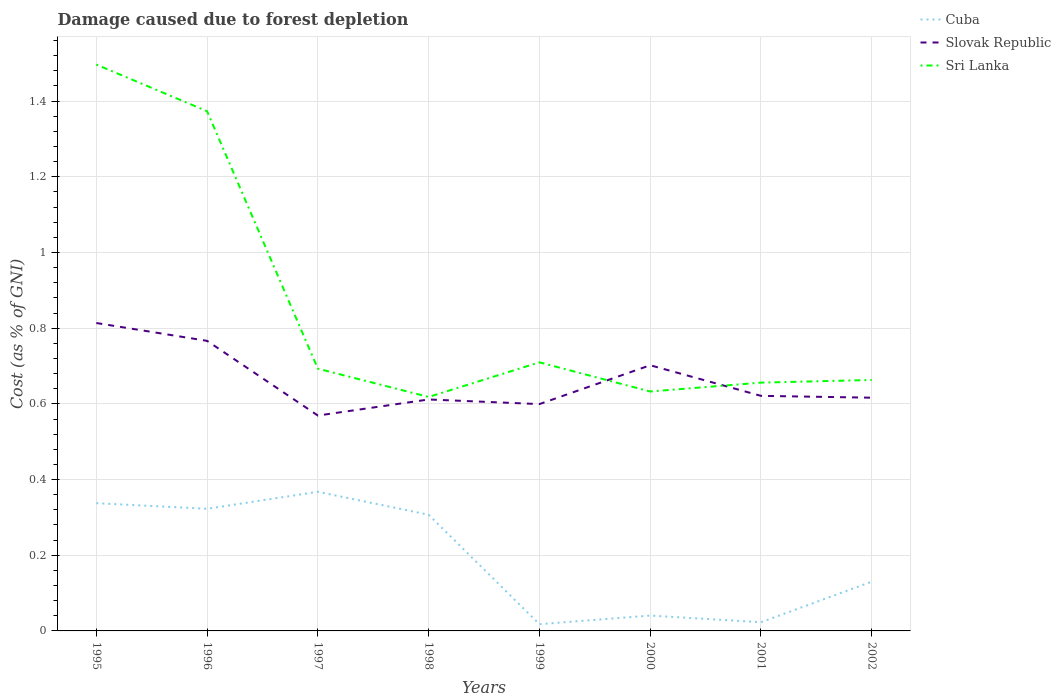How many different coloured lines are there?
Offer a very short reply. 3. Is the number of lines equal to the number of legend labels?
Keep it short and to the point. Yes. Across all years, what is the maximum cost of damage caused due to forest depletion in Sri Lanka?
Your response must be concise. 0.62. In which year was the cost of damage caused due to forest depletion in Cuba maximum?
Make the answer very short. 1999. What is the total cost of damage caused due to forest depletion in Cuba in the graph?
Offer a very short reply. 0.35. What is the difference between the highest and the second highest cost of damage caused due to forest depletion in Slovak Republic?
Offer a terse response. 0.24. What is the difference between the highest and the lowest cost of damage caused due to forest depletion in Slovak Republic?
Your answer should be compact. 3. How many lines are there?
Your answer should be very brief. 3. How many years are there in the graph?
Offer a very short reply. 8. What is the difference between two consecutive major ticks on the Y-axis?
Your response must be concise. 0.2. Does the graph contain grids?
Your answer should be very brief. Yes. How many legend labels are there?
Your answer should be very brief. 3. What is the title of the graph?
Ensure brevity in your answer.  Damage caused due to forest depletion. Does "Bulgaria" appear as one of the legend labels in the graph?
Your response must be concise. No. What is the label or title of the X-axis?
Keep it short and to the point. Years. What is the label or title of the Y-axis?
Your response must be concise. Cost (as % of GNI). What is the Cost (as % of GNI) of Cuba in 1995?
Provide a short and direct response. 0.34. What is the Cost (as % of GNI) of Slovak Republic in 1995?
Your answer should be compact. 0.81. What is the Cost (as % of GNI) in Sri Lanka in 1995?
Ensure brevity in your answer.  1.5. What is the Cost (as % of GNI) in Cuba in 1996?
Your response must be concise. 0.32. What is the Cost (as % of GNI) in Slovak Republic in 1996?
Make the answer very short. 0.77. What is the Cost (as % of GNI) in Sri Lanka in 1996?
Your response must be concise. 1.37. What is the Cost (as % of GNI) in Cuba in 1997?
Ensure brevity in your answer.  0.37. What is the Cost (as % of GNI) in Slovak Republic in 1997?
Your answer should be very brief. 0.57. What is the Cost (as % of GNI) of Sri Lanka in 1997?
Offer a terse response. 0.69. What is the Cost (as % of GNI) of Cuba in 1998?
Offer a terse response. 0.31. What is the Cost (as % of GNI) in Slovak Republic in 1998?
Your answer should be compact. 0.61. What is the Cost (as % of GNI) in Sri Lanka in 1998?
Provide a short and direct response. 0.62. What is the Cost (as % of GNI) of Cuba in 1999?
Offer a very short reply. 0.02. What is the Cost (as % of GNI) of Slovak Republic in 1999?
Your answer should be very brief. 0.6. What is the Cost (as % of GNI) of Sri Lanka in 1999?
Provide a short and direct response. 0.71. What is the Cost (as % of GNI) of Cuba in 2000?
Give a very brief answer. 0.04. What is the Cost (as % of GNI) in Slovak Republic in 2000?
Your answer should be very brief. 0.7. What is the Cost (as % of GNI) of Sri Lanka in 2000?
Offer a terse response. 0.63. What is the Cost (as % of GNI) of Cuba in 2001?
Keep it short and to the point. 0.02. What is the Cost (as % of GNI) in Slovak Republic in 2001?
Provide a short and direct response. 0.62. What is the Cost (as % of GNI) of Sri Lanka in 2001?
Your answer should be compact. 0.66. What is the Cost (as % of GNI) in Cuba in 2002?
Give a very brief answer. 0.13. What is the Cost (as % of GNI) of Slovak Republic in 2002?
Your response must be concise. 0.62. What is the Cost (as % of GNI) of Sri Lanka in 2002?
Offer a very short reply. 0.66. Across all years, what is the maximum Cost (as % of GNI) of Cuba?
Your response must be concise. 0.37. Across all years, what is the maximum Cost (as % of GNI) of Slovak Republic?
Keep it short and to the point. 0.81. Across all years, what is the maximum Cost (as % of GNI) in Sri Lanka?
Your answer should be compact. 1.5. Across all years, what is the minimum Cost (as % of GNI) of Cuba?
Give a very brief answer. 0.02. Across all years, what is the minimum Cost (as % of GNI) in Slovak Republic?
Your answer should be compact. 0.57. Across all years, what is the minimum Cost (as % of GNI) in Sri Lanka?
Provide a short and direct response. 0.62. What is the total Cost (as % of GNI) in Cuba in the graph?
Offer a terse response. 1.55. What is the total Cost (as % of GNI) of Slovak Republic in the graph?
Give a very brief answer. 5.3. What is the total Cost (as % of GNI) of Sri Lanka in the graph?
Your response must be concise. 6.84. What is the difference between the Cost (as % of GNI) in Cuba in 1995 and that in 1996?
Your answer should be very brief. 0.01. What is the difference between the Cost (as % of GNI) in Slovak Republic in 1995 and that in 1996?
Your answer should be very brief. 0.05. What is the difference between the Cost (as % of GNI) of Sri Lanka in 1995 and that in 1996?
Provide a short and direct response. 0.12. What is the difference between the Cost (as % of GNI) of Cuba in 1995 and that in 1997?
Ensure brevity in your answer.  -0.03. What is the difference between the Cost (as % of GNI) in Slovak Republic in 1995 and that in 1997?
Offer a very short reply. 0.24. What is the difference between the Cost (as % of GNI) of Sri Lanka in 1995 and that in 1997?
Keep it short and to the point. 0.8. What is the difference between the Cost (as % of GNI) of Cuba in 1995 and that in 1998?
Keep it short and to the point. 0.03. What is the difference between the Cost (as % of GNI) in Slovak Republic in 1995 and that in 1998?
Your answer should be compact. 0.2. What is the difference between the Cost (as % of GNI) of Sri Lanka in 1995 and that in 1998?
Offer a very short reply. 0.88. What is the difference between the Cost (as % of GNI) in Cuba in 1995 and that in 1999?
Ensure brevity in your answer.  0.32. What is the difference between the Cost (as % of GNI) of Slovak Republic in 1995 and that in 1999?
Provide a short and direct response. 0.21. What is the difference between the Cost (as % of GNI) of Sri Lanka in 1995 and that in 1999?
Your response must be concise. 0.79. What is the difference between the Cost (as % of GNI) of Cuba in 1995 and that in 2000?
Offer a terse response. 0.3. What is the difference between the Cost (as % of GNI) of Slovak Republic in 1995 and that in 2000?
Your answer should be very brief. 0.11. What is the difference between the Cost (as % of GNI) in Sri Lanka in 1995 and that in 2000?
Provide a succinct answer. 0.86. What is the difference between the Cost (as % of GNI) of Cuba in 1995 and that in 2001?
Your response must be concise. 0.31. What is the difference between the Cost (as % of GNI) in Slovak Republic in 1995 and that in 2001?
Give a very brief answer. 0.19. What is the difference between the Cost (as % of GNI) of Sri Lanka in 1995 and that in 2001?
Offer a very short reply. 0.84. What is the difference between the Cost (as % of GNI) of Cuba in 1995 and that in 2002?
Make the answer very short. 0.21. What is the difference between the Cost (as % of GNI) in Slovak Republic in 1995 and that in 2002?
Provide a short and direct response. 0.2. What is the difference between the Cost (as % of GNI) in Sri Lanka in 1995 and that in 2002?
Make the answer very short. 0.83. What is the difference between the Cost (as % of GNI) in Cuba in 1996 and that in 1997?
Your answer should be very brief. -0.04. What is the difference between the Cost (as % of GNI) of Slovak Republic in 1996 and that in 1997?
Ensure brevity in your answer.  0.2. What is the difference between the Cost (as % of GNI) of Sri Lanka in 1996 and that in 1997?
Your answer should be compact. 0.68. What is the difference between the Cost (as % of GNI) of Cuba in 1996 and that in 1998?
Your response must be concise. 0.02. What is the difference between the Cost (as % of GNI) in Slovak Republic in 1996 and that in 1998?
Give a very brief answer. 0.15. What is the difference between the Cost (as % of GNI) of Sri Lanka in 1996 and that in 1998?
Your answer should be very brief. 0.76. What is the difference between the Cost (as % of GNI) of Cuba in 1996 and that in 1999?
Ensure brevity in your answer.  0.3. What is the difference between the Cost (as % of GNI) in Slovak Republic in 1996 and that in 1999?
Offer a very short reply. 0.17. What is the difference between the Cost (as % of GNI) in Sri Lanka in 1996 and that in 1999?
Your response must be concise. 0.66. What is the difference between the Cost (as % of GNI) of Cuba in 1996 and that in 2000?
Provide a short and direct response. 0.28. What is the difference between the Cost (as % of GNI) in Slovak Republic in 1996 and that in 2000?
Keep it short and to the point. 0.06. What is the difference between the Cost (as % of GNI) of Sri Lanka in 1996 and that in 2000?
Ensure brevity in your answer.  0.74. What is the difference between the Cost (as % of GNI) of Cuba in 1996 and that in 2001?
Provide a short and direct response. 0.3. What is the difference between the Cost (as % of GNI) of Slovak Republic in 1996 and that in 2001?
Provide a succinct answer. 0.15. What is the difference between the Cost (as % of GNI) in Sri Lanka in 1996 and that in 2001?
Your response must be concise. 0.72. What is the difference between the Cost (as % of GNI) of Cuba in 1996 and that in 2002?
Provide a short and direct response. 0.19. What is the difference between the Cost (as % of GNI) of Slovak Republic in 1996 and that in 2002?
Your response must be concise. 0.15. What is the difference between the Cost (as % of GNI) of Sri Lanka in 1996 and that in 2002?
Make the answer very short. 0.71. What is the difference between the Cost (as % of GNI) of Cuba in 1997 and that in 1998?
Offer a terse response. 0.06. What is the difference between the Cost (as % of GNI) in Slovak Republic in 1997 and that in 1998?
Provide a succinct answer. -0.04. What is the difference between the Cost (as % of GNI) in Sri Lanka in 1997 and that in 1998?
Offer a terse response. 0.07. What is the difference between the Cost (as % of GNI) of Cuba in 1997 and that in 1999?
Offer a very short reply. 0.35. What is the difference between the Cost (as % of GNI) in Slovak Republic in 1997 and that in 1999?
Ensure brevity in your answer.  -0.03. What is the difference between the Cost (as % of GNI) of Sri Lanka in 1997 and that in 1999?
Offer a terse response. -0.02. What is the difference between the Cost (as % of GNI) of Cuba in 1997 and that in 2000?
Keep it short and to the point. 0.33. What is the difference between the Cost (as % of GNI) of Slovak Republic in 1997 and that in 2000?
Make the answer very short. -0.13. What is the difference between the Cost (as % of GNI) in Sri Lanka in 1997 and that in 2000?
Ensure brevity in your answer.  0.06. What is the difference between the Cost (as % of GNI) in Cuba in 1997 and that in 2001?
Give a very brief answer. 0.34. What is the difference between the Cost (as % of GNI) of Slovak Republic in 1997 and that in 2001?
Keep it short and to the point. -0.05. What is the difference between the Cost (as % of GNI) in Sri Lanka in 1997 and that in 2001?
Ensure brevity in your answer.  0.04. What is the difference between the Cost (as % of GNI) of Cuba in 1997 and that in 2002?
Provide a short and direct response. 0.24. What is the difference between the Cost (as % of GNI) in Slovak Republic in 1997 and that in 2002?
Your answer should be very brief. -0.05. What is the difference between the Cost (as % of GNI) in Sri Lanka in 1997 and that in 2002?
Provide a short and direct response. 0.03. What is the difference between the Cost (as % of GNI) in Cuba in 1998 and that in 1999?
Provide a succinct answer. 0.29. What is the difference between the Cost (as % of GNI) of Slovak Republic in 1998 and that in 1999?
Provide a short and direct response. 0.01. What is the difference between the Cost (as % of GNI) of Sri Lanka in 1998 and that in 1999?
Your answer should be compact. -0.09. What is the difference between the Cost (as % of GNI) in Cuba in 1998 and that in 2000?
Give a very brief answer. 0.27. What is the difference between the Cost (as % of GNI) in Slovak Republic in 1998 and that in 2000?
Your answer should be compact. -0.09. What is the difference between the Cost (as % of GNI) in Sri Lanka in 1998 and that in 2000?
Make the answer very short. -0.01. What is the difference between the Cost (as % of GNI) in Cuba in 1998 and that in 2001?
Offer a very short reply. 0.28. What is the difference between the Cost (as % of GNI) of Slovak Republic in 1998 and that in 2001?
Ensure brevity in your answer.  -0.01. What is the difference between the Cost (as % of GNI) in Sri Lanka in 1998 and that in 2001?
Offer a very short reply. -0.04. What is the difference between the Cost (as % of GNI) of Cuba in 1998 and that in 2002?
Keep it short and to the point. 0.18. What is the difference between the Cost (as % of GNI) in Slovak Republic in 1998 and that in 2002?
Offer a terse response. -0. What is the difference between the Cost (as % of GNI) in Sri Lanka in 1998 and that in 2002?
Your response must be concise. -0.04. What is the difference between the Cost (as % of GNI) in Cuba in 1999 and that in 2000?
Keep it short and to the point. -0.02. What is the difference between the Cost (as % of GNI) in Slovak Republic in 1999 and that in 2000?
Provide a short and direct response. -0.1. What is the difference between the Cost (as % of GNI) of Sri Lanka in 1999 and that in 2000?
Your answer should be compact. 0.08. What is the difference between the Cost (as % of GNI) in Cuba in 1999 and that in 2001?
Offer a terse response. -0.01. What is the difference between the Cost (as % of GNI) of Slovak Republic in 1999 and that in 2001?
Provide a succinct answer. -0.02. What is the difference between the Cost (as % of GNI) in Sri Lanka in 1999 and that in 2001?
Provide a succinct answer. 0.05. What is the difference between the Cost (as % of GNI) in Cuba in 1999 and that in 2002?
Your answer should be compact. -0.11. What is the difference between the Cost (as % of GNI) in Slovak Republic in 1999 and that in 2002?
Provide a short and direct response. -0.02. What is the difference between the Cost (as % of GNI) in Sri Lanka in 1999 and that in 2002?
Your answer should be compact. 0.05. What is the difference between the Cost (as % of GNI) in Cuba in 2000 and that in 2001?
Your answer should be very brief. 0.02. What is the difference between the Cost (as % of GNI) of Slovak Republic in 2000 and that in 2001?
Your answer should be very brief. 0.08. What is the difference between the Cost (as % of GNI) in Sri Lanka in 2000 and that in 2001?
Offer a very short reply. -0.02. What is the difference between the Cost (as % of GNI) of Cuba in 2000 and that in 2002?
Your answer should be very brief. -0.09. What is the difference between the Cost (as % of GNI) of Slovak Republic in 2000 and that in 2002?
Keep it short and to the point. 0.09. What is the difference between the Cost (as % of GNI) in Sri Lanka in 2000 and that in 2002?
Offer a terse response. -0.03. What is the difference between the Cost (as % of GNI) of Cuba in 2001 and that in 2002?
Your answer should be very brief. -0.11. What is the difference between the Cost (as % of GNI) in Slovak Republic in 2001 and that in 2002?
Give a very brief answer. 0. What is the difference between the Cost (as % of GNI) in Sri Lanka in 2001 and that in 2002?
Provide a succinct answer. -0.01. What is the difference between the Cost (as % of GNI) of Cuba in 1995 and the Cost (as % of GNI) of Slovak Republic in 1996?
Make the answer very short. -0.43. What is the difference between the Cost (as % of GNI) in Cuba in 1995 and the Cost (as % of GNI) in Sri Lanka in 1996?
Offer a terse response. -1.04. What is the difference between the Cost (as % of GNI) of Slovak Republic in 1995 and the Cost (as % of GNI) of Sri Lanka in 1996?
Offer a terse response. -0.56. What is the difference between the Cost (as % of GNI) in Cuba in 1995 and the Cost (as % of GNI) in Slovak Republic in 1997?
Make the answer very short. -0.23. What is the difference between the Cost (as % of GNI) of Cuba in 1995 and the Cost (as % of GNI) of Sri Lanka in 1997?
Keep it short and to the point. -0.36. What is the difference between the Cost (as % of GNI) in Slovak Republic in 1995 and the Cost (as % of GNI) in Sri Lanka in 1997?
Your answer should be compact. 0.12. What is the difference between the Cost (as % of GNI) in Cuba in 1995 and the Cost (as % of GNI) in Slovak Republic in 1998?
Make the answer very short. -0.27. What is the difference between the Cost (as % of GNI) in Cuba in 1995 and the Cost (as % of GNI) in Sri Lanka in 1998?
Offer a terse response. -0.28. What is the difference between the Cost (as % of GNI) of Slovak Republic in 1995 and the Cost (as % of GNI) of Sri Lanka in 1998?
Offer a terse response. 0.2. What is the difference between the Cost (as % of GNI) in Cuba in 1995 and the Cost (as % of GNI) in Slovak Republic in 1999?
Give a very brief answer. -0.26. What is the difference between the Cost (as % of GNI) of Cuba in 1995 and the Cost (as % of GNI) of Sri Lanka in 1999?
Provide a succinct answer. -0.37. What is the difference between the Cost (as % of GNI) in Slovak Republic in 1995 and the Cost (as % of GNI) in Sri Lanka in 1999?
Offer a very short reply. 0.1. What is the difference between the Cost (as % of GNI) of Cuba in 1995 and the Cost (as % of GNI) of Slovak Republic in 2000?
Offer a terse response. -0.36. What is the difference between the Cost (as % of GNI) of Cuba in 1995 and the Cost (as % of GNI) of Sri Lanka in 2000?
Give a very brief answer. -0.3. What is the difference between the Cost (as % of GNI) in Slovak Republic in 1995 and the Cost (as % of GNI) in Sri Lanka in 2000?
Your answer should be compact. 0.18. What is the difference between the Cost (as % of GNI) in Cuba in 1995 and the Cost (as % of GNI) in Slovak Republic in 2001?
Provide a succinct answer. -0.28. What is the difference between the Cost (as % of GNI) in Cuba in 1995 and the Cost (as % of GNI) in Sri Lanka in 2001?
Offer a terse response. -0.32. What is the difference between the Cost (as % of GNI) of Slovak Republic in 1995 and the Cost (as % of GNI) of Sri Lanka in 2001?
Give a very brief answer. 0.16. What is the difference between the Cost (as % of GNI) of Cuba in 1995 and the Cost (as % of GNI) of Slovak Republic in 2002?
Keep it short and to the point. -0.28. What is the difference between the Cost (as % of GNI) in Cuba in 1995 and the Cost (as % of GNI) in Sri Lanka in 2002?
Make the answer very short. -0.33. What is the difference between the Cost (as % of GNI) in Slovak Republic in 1995 and the Cost (as % of GNI) in Sri Lanka in 2002?
Your response must be concise. 0.15. What is the difference between the Cost (as % of GNI) in Cuba in 1996 and the Cost (as % of GNI) in Slovak Republic in 1997?
Give a very brief answer. -0.25. What is the difference between the Cost (as % of GNI) of Cuba in 1996 and the Cost (as % of GNI) of Sri Lanka in 1997?
Your response must be concise. -0.37. What is the difference between the Cost (as % of GNI) of Slovak Republic in 1996 and the Cost (as % of GNI) of Sri Lanka in 1997?
Your answer should be very brief. 0.07. What is the difference between the Cost (as % of GNI) of Cuba in 1996 and the Cost (as % of GNI) of Slovak Republic in 1998?
Your response must be concise. -0.29. What is the difference between the Cost (as % of GNI) of Cuba in 1996 and the Cost (as % of GNI) of Sri Lanka in 1998?
Provide a succinct answer. -0.3. What is the difference between the Cost (as % of GNI) in Slovak Republic in 1996 and the Cost (as % of GNI) in Sri Lanka in 1998?
Your answer should be very brief. 0.15. What is the difference between the Cost (as % of GNI) of Cuba in 1996 and the Cost (as % of GNI) of Slovak Republic in 1999?
Make the answer very short. -0.28. What is the difference between the Cost (as % of GNI) of Cuba in 1996 and the Cost (as % of GNI) of Sri Lanka in 1999?
Provide a short and direct response. -0.39. What is the difference between the Cost (as % of GNI) in Slovak Republic in 1996 and the Cost (as % of GNI) in Sri Lanka in 1999?
Your response must be concise. 0.06. What is the difference between the Cost (as % of GNI) in Cuba in 1996 and the Cost (as % of GNI) in Slovak Republic in 2000?
Your answer should be compact. -0.38. What is the difference between the Cost (as % of GNI) in Cuba in 1996 and the Cost (as % of GNI) in Sri Lanka in 2000?
Provide a short and direct response. -0.31. What is the difference between the Cost (as % of GNI) of Slovak Republic in 1996 and the Cost (as % of GNI) of Sri Lanka in 2000?
Make the answer very short. 0.13. What is the difference between the Cost (as % of GNI) of Cuba in 1996 and the Cost (as % of GNI) of Slovak Republic in 2001?
Offer a terse response. -0.3. What is the difference between the Cost (as % of GNI) of Cuba in 1996 and the Cost (as % of GNI) of Sri Lanka in 2001?
Provide a short and direct response. -0.33. What is the difference between the Cost (as % of GNI) in Slovak Republic in 1996 and the Cost (as % of GNI) in Sri Lanka in 2001?
Give a very brief answer. 0.11. What is the difference between the Cost (as % of GNI) in Cuba in 1996 and the Cost (as % of GNI) in Slovak Republic in 2002?
Offer a terse response. -0.29. What is the difference between the Cost (as % of GNI) of Cuba in 1996 and the Cost (as % of GNI) of Sri Lanka in 2002?
Your answer should be compact. -0.34. What is the difference between the Cost (as % of GNI) in Slovak Republic in 1996 and the Cost (as % of GNI) in Sri Lanka in 2002?
Make the answer very short. 0.1. What is the difference between the Cost (as % of GNI) of Cuba in 1997 and the Cost (as % of GNI) of Slovak Republic in 1998?
Your answer should be compact. -0.24. What is the difference between the Cost (as % of GNI) of Cuba in 1997 and the Cost (as % of GNI) of Sri Lanka in 1998?
Give a very brief answer. -0.25. What is the difference between the Cost (as % of GNI) in Slovak Republic in 1997 and the Cost (as % of GNI) in Sri Lanka in 1998?
Provide a succinct answer. -0.05. What is the difference between the Cost (as % of GNI) in Cuba in 1997 and the Cost (as % of GNI) in Slovak Republic in 1999?
Make the answer very short. -0.23. What is the difference between the Cost (as % of GNI) of Cuba in 1997 and the Cost (as % of GNI) of Sri Lanka in 1999?
Provide a short and direct response. -0.34. What is the difference between the Cost (as % of GNI) in Slovak Republic in 1997 and the Cost (as % of GNI) in Sri Lanka in 1999?
Offer a very short reply. -0.14. What is the difference between the Cost (as % of GNI) of Cuba in 1997 and the Cost (as % of GNI) of Slovak Republic in 2000?
Ensure brevity in your answer.  -0.33. What is the difference between the Cost (as % of GNI) in Cuba in 1997 and the Cost (as % of GNI) in Sri Lanka in 2000?
Give a very brief answer. -0.27. What is the difference between the Cost (as % of GNI) of Slovak Republic in 1997 and the Cost (as % of GNI) of Sri Lanka in 2000?
Your response must be concise. -0.06. What is the difference between the Cost (as % of GNI) in Cuba in 1997 and the Cost (as % of GNI) in Slovak Republic in 2001?
Make the answer very short. -0.25. What is the difference between the Cost (as % of GNI) in Cuba in 1997 and the Cost (as % of GNI) in Sri Lanka in 2001?
Offer a terse response. -0.29. What is the difference between the Cost (as % of GNI) in Slovak Republic in 1997 and the Cost (as % of GNI) in Sri Lanka in 2001?
Your response must be concise. -0.09. What is the difference between the Cost (as % of GNI) in Cuba in 1997 and the Cost (as % of GNI) in Slovak Republic in 2002?
Your response must be concise. -0.25. What is the difference between the Cost (as % of GNI) in Cuba in 1997 and the Cost (as % of GNI) in Sri Lanka in 2002?
Your answer should be compact. -0.3. What is the difference between the Cost (as % of GNI) in Slovak Republic in 1997 and the Cost (as % of GNI) in Sri Lanka in 2002?
Give a very brief answer. -0.09. What is the difference between the Cost (as % of GNI) in Cuba in 1998 and the Cost (as % of GNI) in Slovak Republic in 1999?
Give a very brief answer. -0.29. What is the difference between the Cost (as % of GNI) in Cuba in 1998 and the Cost (as % of GNI) in Sri Lanka in 1999?
Give a very brief answer. -0.4. What is the difference between the Cost (as % of GNI) in Slovak Republic in 1998 and the Cost (as % of GNI) in Sri Lanka in 1999?
Give a very brief answer. -0.1. What is the difference between the Cost (as % of GNI) of Cuba in 1998 and the Cost (as % of GNI) of Slovak Republic in 2000?
Give a very brief answer. -0.4. What is the difference between the Cost (as % of GNI) in Cuba in 1998 and the Cost (as % of GNI) in Sri Lanka in 2000?
Offer a terse response. -0.33. What is the difference between the Cost (as % of GNI) of Slovak Republic in 1998 and the Cost (as % of GNI) of Sri Lanka in 2000?
Offer a very short reply. -0.02. What is the difference between the Cost (as % of GNI) in Cuba in 1998 and the Cost (as % of GNI) in Slovak Republic in 2001?
Your response must be concise. -0.31. What is the difference between the Cost (as % of GNI) of Cuba in 1998 and the Cost (as % of GNI) of Sri Lanka in 2001?
Your answer should be very brief. -0.35. What is the difference between the Cost (as % of GNI) of Slovak Republic in 1998 and the Cost (as % of GNI) of Sri Lanka in 2001?
Your answer should be compact. -0.04. What is the difference between the Cost (as % of GNI) in Cuba in 1998 and the Cost (as % of GNI) in Slovak Republic in 2002?
Your answer should be compact. -0.31. What is the difference between the Cost (as % of GNI) in Cuba in 1998 and the Cost (as % of GNI) in Sri Lanka in 2002?
Make the answer very short. -0.36. What is the difference between the Cost (as % of GNI) of Slovak Republic in 1998 and the Cost (as % of GNI) of Sri Lanka in 2002?
Offer a terse response. -0.05. What is the difference between the Cost (as % of GNI) of Cuba in 1999 and the Cost (as % of GNI) of Slovak Republic in 2000?
Make the answer very short. -0.68. What is the difference between the Cost (as % of GNI) of Cuba in 1999 and the Cost (as % of GNI) of Sri Lanka in 2000?
Ensure brevity in your answer.  -0.61. What is the difference between the Cost (as % of GNI) in Slovak Republic in 1999 and the Cost (as % of GNI) in Sri Lanka in 2000?
Your answer should be very brief. -0.03. What is the difference between the Cost (as % of GNI) of Cuba in 1999 and the Cost (as % of GNI) of Slovak Republic in 2001?
Provide a short and direct response. -0.6. What is the difference between the Cost (as % of GNI) in Cuba in 1999 and the Cost (as % of GNI) in Sri Lanka in 2001?
Your answer should be very brief. -0.64. What is the difference between the Cost (as % of GNI) of Slovak Republic in 1999 and the Cost (as % of GNI) of Sri Lanka in 2001?
Provide a succinct answer. -0.06. What is the difference between the Cost (as % of GNI) of Cuba in 1999 and the Cost (as % of GNI) of Slovak Republic in 2002?
Your answer should be very brief. -0.6. What is the difference between the Cost (as % of GNI) of Cuba in 1999 and the Cost (as % of GNI) of Sri Lanka in 2002?
Provide a short and direct response. -0.65. What is the difference between the Cost (as % of GNI) of Slovak Republic in 1999 and the Cost (as % of GNI) of Sri Lanka in 2002?
Ensure brevity in your answer.  -0.06. What is the difference between the Cost (as % of GNI) in Cuba in 2000 and the Cost (as % of GNI) in Slovak Republic in 2001?
Offer a very short reply. -0.58. What is the difference between the Cost (as % of GNI) in Cuba in 2000 and the Cost (as % of GNI) in Sri Lanka in 2001?
Your answer should be compact. -0.62. What is the difference between the Cost (as % of GNI) in Slovak Republic in 2000 and the Cost (as % of GNI) in Sri Lanka in 2001?
Your response must be concise. 0.05. What is the difference between the Cost (as % of GNI) in Cuba in 2000 and the Cost (as % of GNI) in Slovak Republic in 2002?
Keep it short and to the point. -0.58. What is the difference between the Cost (as % of GNI) of Cuba in 2000 and the Cost (as % of GNI) of Sri Lanka in 2002?
Give a very brief answer. -0.62. What is the difference between the Cost (as % of GNI) of Slovak Republic in 2000 and the Cost (as % of GNI) of Sri Lanka in 2002?
Your answer should be very brief. 0.04. What is the difference between the Cost (as % of GNI) of Cuba in 2001 and the Cost (as % of GNI) of Slovak Republic in 2002?
Offer a very short reply. -0.59. What is the difference between the Cost (as % of GNI) in Cuba in 2001 and the Cost (as % of GNI) in Sri Lanka in 2002?
Offer a very short reply. -0.64. What is the difference between the Cost (as % of GNI) in Slovak Republic in 2001 and the Cost (as % of GNI) in Sri Lanka in 2002?
Your answer should be compact. -0.04. What is the average Cost (as % of GNI) of Cuba per year?
Provide a succinct answer. 0.19. What is the average Cost (as % of GNI) in Slovak Republic per year?
Ensure brevity in your answer.  0.66. What is the average Cost (as % of GNI) of Sri Lanka per year?
Make the answer very short. 0.86. In the year 1995, what is the difference between the Cost (as % of GNI) in Cuba and Cost (as % of GNI) in Slovak Republic?
Your response must be concise. -0.48. In the year 1995, what is the difference between the Cost (as % of GNI) in Cuba and Cost (as % of GNI) in Sri Lanka?
Provide a short and direct response. -1.16. In the year 1995, what is the difference between the Cost (as % of GNI) in Slovak Republic and Cost (as % of GNI) in Sri Lanka?
Your answer should be compact. -0.68. In the year 1996, what is the difference between the Cost (as % of GNI) in Cuba and Cost (as % of GNI) in Slovak Republic?
Keep it short and to the point. -0.44. In the year 1996, what is the difference between the Cost (as % of GNI) of Cuba and Cost (as % of GNI) of Sri Lanka?
Your response must be concise. -1.05. In the year 1996, what is the difference between the Cost (as % of GNI) of Slovak Republic and Cost (as % of GNI) of Sri Lanka?
Your answer should be very brief. -0.61. In the year 1997, what is the difference between the Cost (as % of GNI) of Cuba and Cost (as % of GNI) of Slovak Republic?
Your response must be concise. -0.2. In the year 1997, what is the difference between the Cost (as % of GNI) in Cuba and Cost (as % of GNI) in Sri Lanka?
Your answer should be compact. -0.33. In the year 1997, what is the difference between the Cost (as % of GNI) in Slovak Republic and Cost (as % of GNI) in Sri Lanka?
Give a very brief answer. -0.12. In the year 1998, what is the difference between the Cost (as % of GNI) in Cuba and Cost (as % of GNI) in Slovak Republic?
Give a very brief answer. -0.3. In the year 1998, what is the difference between the Cost (as % of GNI) in Cuba and Cost (as % of GNI) in Sri Lanka?
Your answer should be very brief. -0.31. In the year 1998, what is the difference between the Cost (as % of GNI) of Slovak Republic and Cost (as % of GNI) of Sri Lanka?
Offer a very short reply. -0.01. In the year 1999, what is the difference between the Cost (as % of GNI) in Cuba and Cost (as % of GNI) in Slovak Republic?
Offer a very short reply. -0.58. In the year 1999, what is the difference between the Cost (as % of GNI) in Cuba and Cost (as % of GNI) in Sri Lanka?
Keep it short and to the point. -0.69. In the year 1999, what is the difference between the Cost (as % of GNI) in Slovak Republic and Cost (as % of GNI) in Sri Lanka?
Offer a terse response. -0.11. In the year 2000, what is the difference between the Cost (as % of GNI) in Cuba and Cost (as % of GNI) in Slovak Republic?
Provide a succinct answer. -0.66. In the year 2000, what is the difference between the Cost (as % of GNI) in Cuba and Cost (as % of GNI) in Sri Lanka?
Provide a succinct answer. -0.59. In the year 2000, what is the difference between the Cost (as % of GNI) of Slovak Republic and Cost (as % of GNI) of Sri Lanka?
Your answer should be very brief. 0.07. In the year 2001, what is the difference between the Cost (as % of GNI) in Cuba and Cost (as % of GNI) in Slovak Republic?
Provide a short and direct response. -0.6. In the year 2001, what is the difference between the Cost (as % of GNI) of Cuba and Cost (as % of GNI) of Sri Lanka?
Provide a succinct answer. -0.63. In the year 2001, what is the difference between the Cost (as % of GNI) of Slovak Republic and Cost (as % of GNI) of Sri Lanka?
Provide a succinct answer. -0.03. In the year 2002, what is the difference between the Cost (as % of GNI) in Cuba and Cost (as % of GNI) in Slovak Republic?
Offer a very short reply. -0.49. In the year 2002, what is the difference between the Cost (as % of GNI) in Cuba and Cost (as % of GNI) in Sri Lanka?
Your response must be concise. -0.53. In the year 2002, what is the difference between the Cost (as % of GNI) of Slovak Republic and Cost (as % of GNI) of Sri Lanka?
Offer a terse response. -0.05. What is the ratio of the Cost (as % of GNI) in Cuba in 1995 to that in 1996?
Offer a very short reply. 1.05. What is the ratio of the Cost (as % of GNI) in Slovak Republic in 1995 to that in 1996?
Ensure brevity in your answer.  1.06. What is the ratio of the Cost (as % of GNI) of Sri Lanka in 1995 to that in 1996?
Provide a succinct answer. 1.09. What is the ratio of the Cost (as % of GNI) of Cuba in 1995 to that in 1997?
Your answer should be very brief. 0.92. What is the ratio of the Cost (as % of GNI) of Slovak Republic in 1995 to that in 1997?
Give a very brief answer. 1.43. What is the ratio of the Cost (as % of GNI) of Sri Lanka in 1995 to that in 1997?
Give a very brief answer. 2.16. What is the ratio of the Cost (as % of GNI) of Cuba in 1995 to that in 1998?
Ensure brevity in your answer.  1.1. What is the ratio of the Cost (as % of GNI) of Slovak Republic in 1995 to that in 1998?
Give a very brief answer. 1.33. What is the ratio of the Cost (as % of GNI) of Sri Lanka in 1995 to that in 1998?
Ensure brevity in your answer.  2.42. What is the ratio of the Cost (as % of GNI) in Cuba in 1995 to that in 1999?
Offer a very short reply. 18.94. What is the ratio of the Cost (as % of GNI) of Slovak Republic in 1995 to that in 1999?
Your answer should be compact. 1.36. What is the ratio of the Cost (as % of GNI) of Sri Lanka in 1995 to that in 1999?
Your response must be concise. 2.11. What is the ratio of the Cost (as % of GNI) in Cuba in 1995 to that in 2000?
Provide a short and direct response. 8.32. What is the ratio of the Cost (as % of GNI) in Slovak Republic in 1995 to that in 2000?
Your response must be concise. 1.16. What is the ratio of the Cost (as % of GNI) in Sri Lanka in 1995 to that in 2000?
Provide a short and direct response. 2.37. What is the ratio of the Cost (as % of GNI) of Cuba in 1995 to that in 2001?
Your response must be concise. 14.7. What is the ratio of the Cost (as % of GNI) in Slovak Republic in 1995 to that in 2001?
Make the answer very short. 1.31. What is the ratio of the Cost (as % of GNI) in Sri Lanka in 1995 to that in 2001?
Provide a short and direct response. 2.28. What is the ratio of the Cost (as % of GNI) in Cuba in 1995 to that in 2002?
Your answer should be very brief. 2.59. What is the ratio of the Cost (as % of GNI) in Slovak Republic in 1995 to that in 2002?
Your response must be concise. 1.32. What is the ratio of the Cost (as % of GNI) in Sri Lanka in 1995 to that in 2002?
Keep it short and to the point. 2.26. What is the ratio of the Cost (as % of GNI) in Cuba in 1996 to that in 1997?
Your response must be concise. 0.88. What is the ratio of the Cost (as % of GNI) in Slovak Republic in 1996 to that in 1997?
Provide a succinct answer. 1.35. What is the ratio of the Cost (as % of GNI) in Sri Lanka in 1996 to that in 1997?
Your response must be concise. 1.98. What is the ratio of the Cost (as % of GNI) of Cuba in 1996 to that in 1998?
Offer a very short reply. 1.05. What is the ratio of the Cost (as % of GNI) in Slovak Republic in 1996 to that in 1998?
Ensure brevity in your answer.  1.25. What is the ratio of the Cost (as % of GNI) of Sri Lanka in 1996 to that in 1998?
Provide a succinct answer. 2.22. What is the ratio of the Cost (as % of GNI) of Cuba in 1996 to that in 1999?
Offer a very short reply. 18.1. What is the ratio of the Cost (as % of GNI) in Slovak Republic in 1996 to that in 1999?
Make the answer very short. 1.28. What is the ratio of the Cost (as % of GNI) of Sri Lanka in 1996 to that in 1999?
Keep it short and to the point. 1.94. What is the ratio of the Cost (as % of GNI) in Cuba in 1996 to that in 2000?
Offer a very short reply. 7.96. What is the ratio of the Cost (as % of GNI) in Slovak Republic in 1996 to that in 2000?
Ensure brevity in your answer.  1.09. What is the ratio of the Cost (as % of GNI) of Sri Lanka in 1996 to that in 2000?
Provide a short and direct response. 2.17. What is the ratio of the Cost (as % of GNI) of Cuba in 1996 to that in 2001?
Make the answer very short. 14.05. What is the ratio of the Cost (as % of GNI) in Slovak Republic in 1996 to that in 2001?
Your answer should be very brief. 1.23. What is the ratio of the Cost (as % of GNI) of Sri Lanka in 1996 to that in 2001?
Give a very brief answer. 2.09. What is the ratio of the Cost (as % of GNI) in Cuba in 1996 to that in 2002?
Provide a short and direct response. 2.48. What is the ratio of the Cost (as % of GNI) of Slovak Republic in 1996 to that in 2002?
Your response must be concise. 1.24. What is the ratio of the Cost (as % of GNI) of Sri Lanka in 1996 to that in 2002?
Keep it short and to the point. 2.07. What is the ratio of the Cost (as % of GNI) in Cuba in 1997 to that in 1998?
Offer a terse response. 1.2. What is the ratio of the Cost (as % of GNI) in Slovak Republic in 1997 to that in 1998?
Make the answer very short. 0.93. What is the ratio of the Cost (as % of GNI) in Sri Lanka in 1997 to that in 1998?
Ensure brevity in your answer.  1.12. What is the ratio of the Cost (as % of GNI) of Cuba in 1997 to that in 1999?
Provide a short and direct response. 20.63. What is the ratio of the Cost (as % of GNI) in Slovak Republic in 1997 to that in 1999?
Keep it short and to the point. 0.95. What is the ratio of the Cost (as % of GNI) of Sri Lanka in 1997 to that in 1999?
Keep it short and to the point. 0.98. What is the ratio of the Cost (as % of GNI) in Cuba in 1997 to that in 2000?
Provide a short and direct response. 9.07. What is the ratio of the Cost (as % of GNI) of Slovak Republic in 1997 to that in 2000?
Your answer should be compact. 0.81. What is the ratio of the Cost (as % of GNI) of Sri Lanka in 1997 to that in 2000?
Ensure brevity in your answer.  1.1. What is the ratio of the Cost (as % of GNI) in Cuba in 1997 to that in 2001?
Keep it short and to the point. 16.01. What is the ratio of the Cost (as % of GNI) of Slovak Republic in 1997 to that in 2001?
Give a very brief answer. 0.92. What is the ratio of the Cost (as % of GNI) of Sri Lanka in 1997 to that in 2001?
Your answer should be very brief. 1.06. What is the ratio of the Cost (as % of GNI) in Cuba in 1997 to that in 2002?
Give a very brief answer. 2.83. What is the ratio of the Cost (as % of GNI) in Slovak Republic in 1997 to that in 2002?
Offer a terse response. 0.92. What is the ratio of the Cost (as % of GNI) in Sri Lanka in 1997 to that in 2002?
Your response must be concise. 1.04. What is the ratio of the Cost (as % of GNI) of Cuba in 1998 to that in 1999?
Keep it short and to the point. 17.22. What is the ratio of the Cost (as % of GNI) in Slovak Republic in 1998 to that in 1999?
Your response must be concise. 1.02. What is the ratio of the Cost (as % of GNI) of Sri Lanka in 1998 to that in 1999?
Your response must be concise. 0.87. What is the ratio of the Cost (as % of GNI) of Cuba in 1998 to that in 2000?
Offer a very short reply. 7.57. What is the ratio of the Cost (as % of GNI) in Slovak Republic in 1998 to that in 2000?
Offer a terse response. 0.87. What is the ratio of the Cost (as % of GNI) in Sri Lanka in 1998 to that in 2000?
Offer a terse response. 0.98. What is the ratio of the Cost (as % of GNI) of Cuba in 1998 to that in 2001?
Your response must be concise. 13.37. What is the ratio of the Cost (as % of GNI) of Slovak Republic in 1998 to that in 2001?
Provide a short and direct response. 0.98. What is the ratio of the Cost (as % of GNI) of Sri Lanka in 1998 to that in 2001?
Your response must be concise. 0.94. What is the ratio of the Cost (as % of GNI) of Cuba in 1998 to that in 2002?
Your answer should be compact. 2.36. What is the ratio of the Cost (as % of GNI) of Sri Lanka in 1998 to that in 2002?
Your answer should be very brief. 0.93. What is the ratio of the Cost (as % of GNI) of Cuba in 1999 to that in 2000?
Your response must be concise. 0.44. What is the ratio of the Cost (as % of GNI) of Slovak Republic in 1999 to that in 2000?
Your response must be concise. 0.85. What is the ratio of the Cost (as % of GNI) in Sri Lanka in 1999 to that in 2000?
Make the answer very short. 1.12. What is the ratio of the Cost (as % of GNI) in Cuba in 1999 to that in 2001?
Offer a terse response. 0.78. What is the ratio of the Cost (as % of GNI) in Slovak Republic in 1999 to that in 2001?
Offer a terse response. 0.96. What is the ratio of the Cost (as % of GNI) in Sri Lanka in 1999 to that in 2001?
Keep it short and to the point. 1.08. What is the ratio of the Cost (as % of GNI) in Cuba in 1999 to that in 2002?
Give a very brief answer. 0.14. What is the ratio of the Cost (as % of GNI) of Slovak Republic in 1999 to that in 2002?
Give a very brief answer. 0.97. What is the ratio of the Cost (as % of GNI) in Sri Lanka in 1999 to that in 2002?
Give a very brief answer. 1.07. What is the ratio of the Cost (as % of GNI) of Cuba in 2000 to that in 2001?
Offer a terse response. 1.77. What is the ratio of the Cost (as % of GNI) of Slovak Republic in 2000 to that in 2001?
Offer a terse response. 1.13. What is the ratio of the Cost (as % of GNI) in Cuba in 2000 to that in 2002?
Your response must be concise. 0.31. What is the ratio of the Cost (as % of GNI) of Slovak Republic in 2000 to that in 2002?
Your answer should be compact. 1.14. What is the ratio of the Cost (as % of GNI) of Sri Lanka in 2000 to that in 2002?
Provide a succinct answer. 0.95. What is the ratio of the Cost (as % of GNI) of Cuba in 2001 to that in 2002?
Give a very brief answer. 0.18. What is the ratio of the Cost (as % of GNI) in Slovak Republic in 2001 to that in 2002?
Offer a terse response. 1.01. What is the difference between the highest and the second highest Cost (as % of GNI) in Cuba?
Provide a succinct answer. 0.03. What is the difference between the highest and the second highest Cost (as % of GNI) in Slovak Republic?
Give a very brief answer. 0.05. What is the difference between the highest and the second highest Cost (as % of GNI) in Sri Lanka?
Offer a terse response. 0.12. What is the difference between the highest and the lowest Cost (as % of GNI) in Cuba?
Provide a succinct answer. 0.35. What is the difference between the highest and the lowest Cost (as % of GNI) of Slovak Republic?
Keep it short and to the point. 0.24. What is the difference between the highest and the lowest Cost (as % of GNI) in Sri Lanka?
Provide a short and direct response. 0.88. 